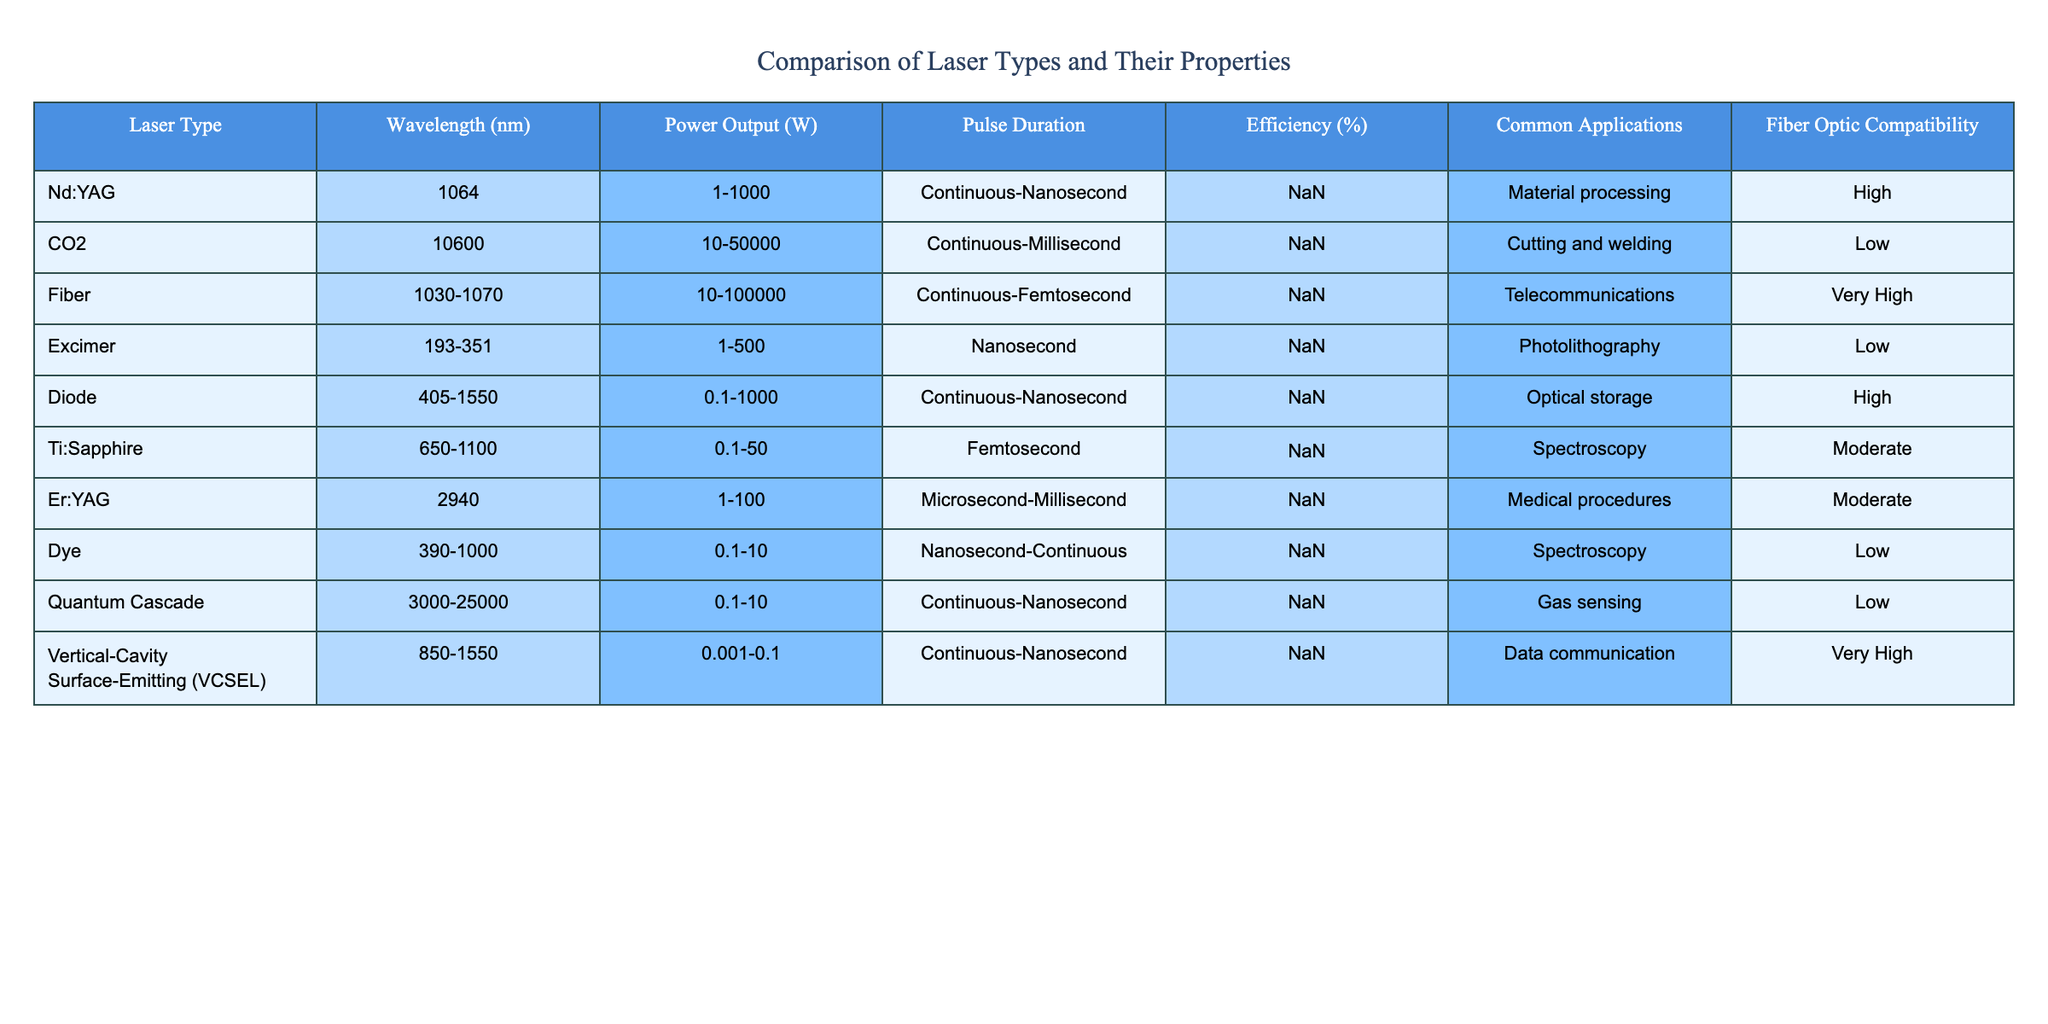What is the power output range for Fiber lasers? The table shows the power output for Fiber lasers ranges from 10 to 100000 watts.
Answer: 10-100000 W Which laser type has the highest efficiency? By examining the efficiency column, the Fiber laser has the highest efficiency at 30-40%.
Answer: Fiber laser How many laser types have a pulse duration in the nanosecond range? The table lists five laser types with a pulse duration in the nanosecond range: Nd:YAG, Excimer, Diode, and VCSEL.
Answer: 4 Is the CO2 laser compatible with fiber optics? The table states that CO2 lasers have low fiber optic compatibility.
Answer: No What is the average wavelength of the Nd:YAG and Er:YAG lasers? Nd:YAG has a wavelength of 1064 nm and Er:YAG has a wavelength of 2940 nm; adding them gives 4064 nm, and dividing by two gives an average of 2032 nm.
Answer: 2032 nm How many laser types have a power output above 500 W? The laser types with power output above 500 W from the table are the CO2 laser, Fiber laser, and Diode laser—summarizing shows that 3 types exceed 500 W in power output.
Answer: 3 Is it true that both the Diode and Excimer lasers have high fiber optic compatibility? The table indicates that the Diode laser has high compatibility, but the Excimer laser has low compatibility, making the statement false.
Answer: False Which laser type commonly used for telecommunications has the highest efficiency? The Fiber laser is used in telecommunications and has an efficiency of 30-40%, which is the highest among the lasers listed for such application.
Answer: Fiber laser What is the difference in efficiency between the Nd:YAG and Er:YAG lasers? The Nd:YAG laser's efficiency is between 20-30%, while Er:YAG's efficiency is between 1-3%. Therefore, the difference in efficiency is approximately 20-30% - 1-3%.
Answer: 19-29% How many lasers have a pulse duration longer than 1 millisecond? The CO2 laser has a pulse duration of milliseconds, and also the Er:YAG has microsecond to millisecond duration—only these two types fit the criterion, hence the count is 2.
Answer: 2 